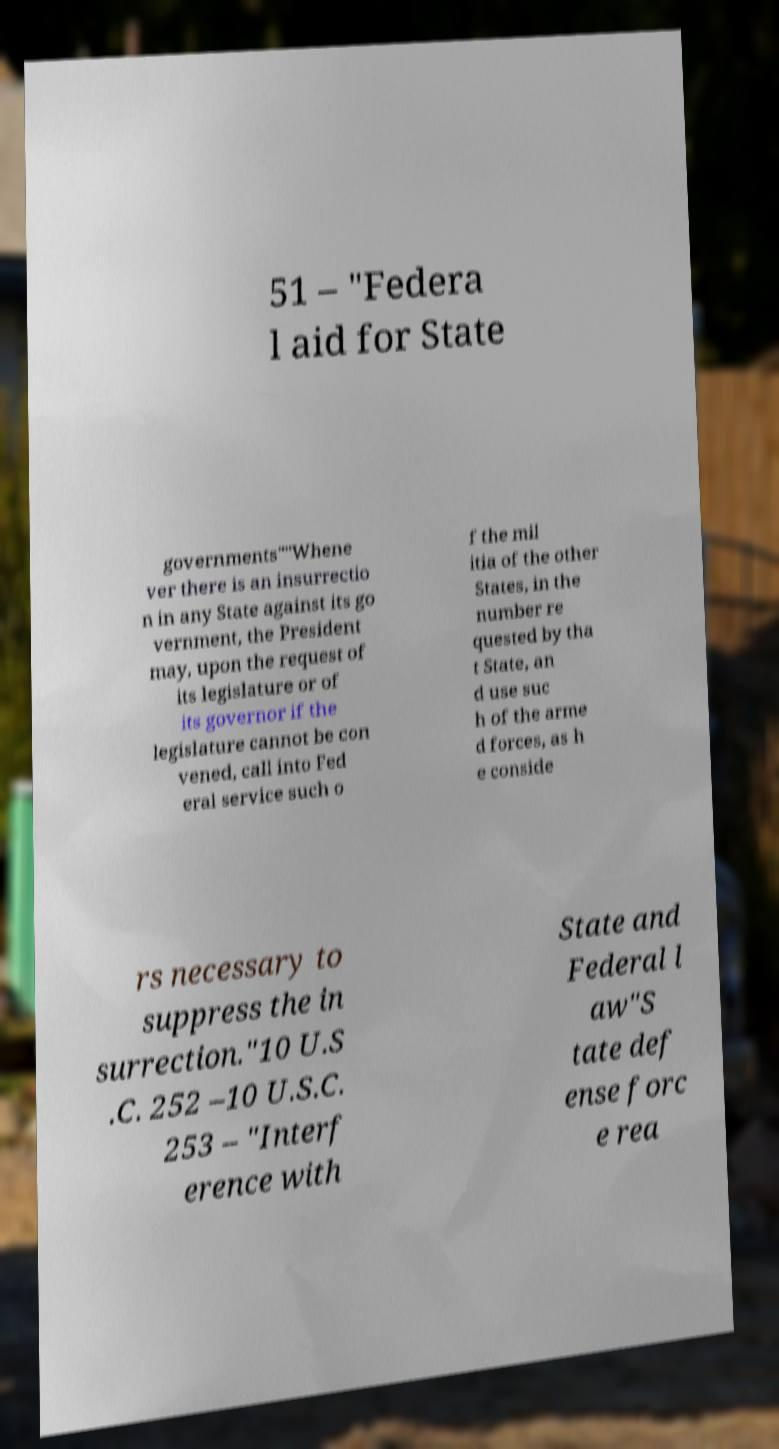Could you assist in decoding the text presented in this image and type it out clearly? 51 – "Federa l aid for State governments""Whene ver there is an insurrectio n in any State against its go vernment, the President may, upon the request of its legislature or of its governor if the legislature cannot be con vened, call into Fed eral service such o f the mil itia of the other States, in the number re quested by tha t State, an d use suc h of the arme d forces, as h e conside rs necessary to suppress the in surrection."10 U.S .C. 252 –10 U.S.C. 253 – "Interf erence with State and Federal l aw"S tate def ense forc e rea 